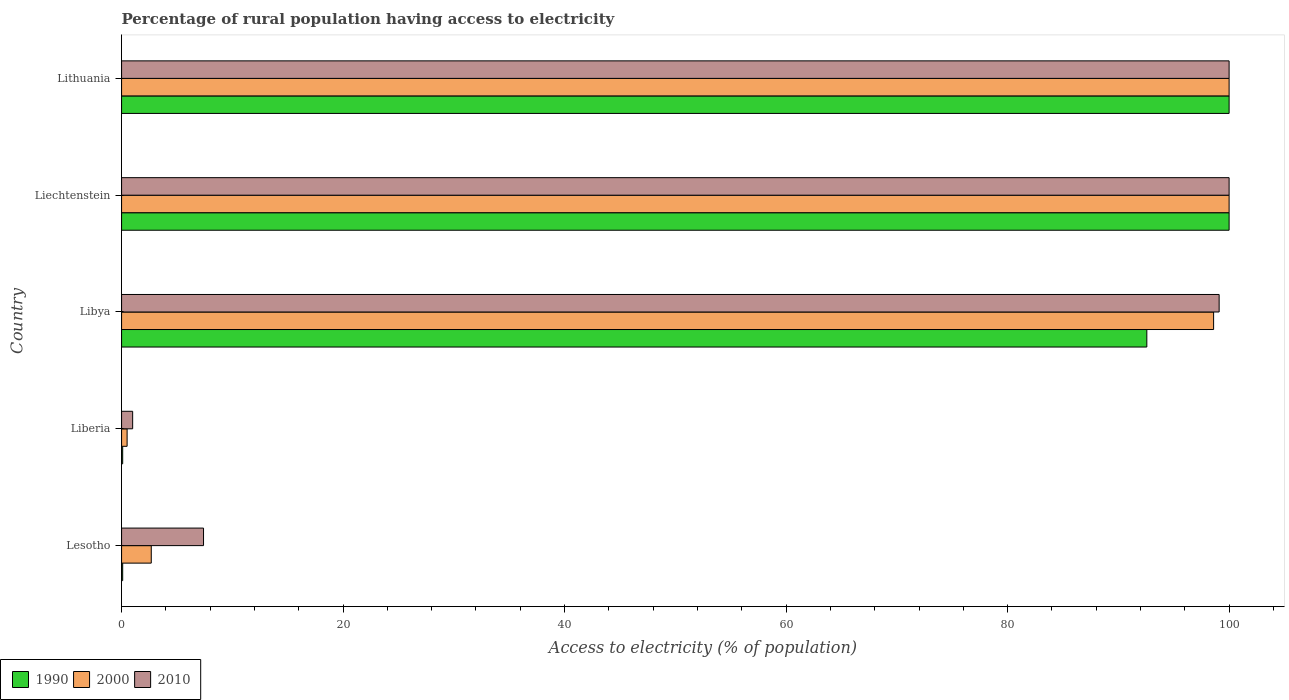How many different coloured bars are there?
Give a very brief answer. 3. How many groups of bars are there?
Offer a very short reply. 5. Are the number of bars per tick equal to the number of legend labels?
Make the answer very short. Yes. Are the number of bars on each tick of the Y-axis equal?
Offer a very short reply. Yes. What is the label of the 1st group of bars from the top?
Provide a short and direct response. Lithuania. In how many cases, is the number of bars for a given country not equal to the number of legend labels?
Provide a succinct answer. 0. What is the percentage of rural population having access to electricity in 1990 in Libya?
Provide a succinct answer. 92.57. Across all countries, what is the minimum percentage of rural population having access to electricity in 2000?
Your answer should be compact. 0.5. In which country was the percentage of rural population having access to electricity in 2000 maximum?
Ensure brevity in your answer.  Liechtenstein. In which country was the percentage of rural population having access to electricity in 2010 minimum?
Offer a very short reply. Liberia. What is the total percentage of rural population having access to electricity in 2010 in the graph?
Ensure brevity in your answer.  307.5. What is the difference between the percentage of rural population having access to electricity in 2000 in Lesotho and that in Libya?
Keep it short and to the point. -95.92. What is the difference between the percentage of rural population having access to electricity in 2010 in Lesotho and the percentage of rural population having access to electricity in 2000 in Libya?
Keep it short and to the point. -91.2. What is the average percentage of rural population having access to electricity in 2010 per country?
Ensure brevity in your answer.  61.5. What is the difference between the percentage of rural population having access to electricity in 1990 and percentage of rural population having access to electricity in 2010 in Liberia?
Your response must be concise. -0.9. In how many countries, is the percentage of rural population having access to electricity in 2000 greater than 92 %?
Keep it short and to the point. 3. What is the ratio of the percentage of rural population having access to electricity in 1990 in Libya to that in Lithuania?
Keep it short and to the point. 0.93. Is the percentage of rural population having access to electricity in 2000 in Liechtenstein less than that in Lithuania?
Your answer should be very brief. No. Is the sum of the percentage of rural population having access to electricity in 1990 in Lesotho and Liechtenstein greater than the maximum percentage of rural population having access to electricity in 2000 across all countries?
Offer a terse response. Yes. What does the 3rd bar from the top in Liechtenstein represents?
Offer a very short reply. 1990. What does the 2nd bar from the bottom in Libya represents?
Your answer should be very brief. 2000. Is it the case that in every country, the sum of the percentage of rural population having access to electricity in 2000 and percentage of rural population having access to electricity in 2010 is greater than the percentage of rural population having access to electricity in 1990?
Provide a succinct answer. Yes. How many bars are there?
Your answer should be compact. 15. How many countries are there in the graph?
Offer a terse response. 5. What is the difference between two consecutive major ticks on the X-axis?
Offer a very short reply. 20. Does the graph contain any zero values?
Ensure brevity in your answer.  No. Where does the legend appear in the graph?
Offer a very short reply. Bottom left. What is the title of the graph?
Offer a very short reply. Percentage of rural population having access to electricity. Does "1978" appear as one of the legend labels in the graph?
Give a very brief answer. No. What is the label or title of the X-axis?
Provide a succinct answer. Access to electricity (% of population). What is the Access to electricity (% of population) of 1990 in Lesotho?
Make the answer very short. 0.1. What is the Access to electricity (% of population) in 2000 in Lesotho?
Offer a terse response. 2.68. What is the Access to electricity (% of population) in 2010 in Lesotho?
Offer a terse response. 7.4. What is the Access to electricity (% of population) of 1990 in Liberia?
Give a very brief answer. 0.1. What is the Access to electricity (% of population) in 2000 in Liberia?
Your answer should be compact. 0.5. What is the Access to electricity (% of population) of 2010 in Liberia?
Offer a very short reply. 1. What is the Access to electricity (% of population) of 1990 in Libya?
Provide a short and direct response. 92.57. What is the Access to electricity (% of population) of 2000 in Libya?
Your response must be concise. 98.6. What is the Access to electricity (% of population) in 2010 in Libya?
Your answer should be compact. 99.1. What is the Access to electricity (% of population) in 1990 in Liechtenstein?
Your answer should be compact. 100. What is the Access to electricity (% of population) of 2010 in Liechtenstein?
Keep it short and to the point. 100. Across all countries, what is the maximum Access to electricity (% of population) in 1990?
Give a very brief answer. 100. What is the total Access to electricity (% of population) in 1990 in the graph?
Provide a short and direct response. 292.77. What is the total Access to electricity (% of population) in 2000 in the graph?
Offer a very short reply. 301.78. What is the total Access to electricity (% of population) in 2010 in the graph?
Give a very brief answer. 307.5. What is the difference between the Access to electricity (% of population) in 1990 in Lesotho and that in Liberia?
Your response must be concise. 0. What is the difference between the Access to electricity (% of population) of 2000 in Lesotho and that in Liberia?
Keep it short and to the point. 2.18. What is the difference between the Access to electricity (% of population) in 1990 in Lesotho and that in Libya?
Keep it short and to the point. -92.47. What is the difference between the Access to electricity (% of population) in 2000 in Lesotho and that in Libya?
Keep it short and to the point. -95.92. What is the difference between the Access to electricity (% of population) in 2010 in Lesotho and that in Libya?
Offer a very short reply. -91.7. What is the difference between the Access to electricity (% of population) in 1990 in Lesotho and that in Liechtenstein?
Provide a succinct answer. -99.9. What is the difference between the Access to electricity (% of population) in 2000 in Lesotho and that in Liechtenstein?
Keep it short and to the point. -97.32. What is the difference between the Access to electricity (% of population) of 2010 in Lesotho and that in Liechtenstein?
Offer a very short reply. -92.6. What is the difference between the Access to electricity (% of population) of 1990 in Lesotho and that in Lithuania?
Make the answer very short. -99.9. What is the difference between the Access to electricity (% of population) in 2000 in Lesotho and that in Lithuania?
Your answer should be compact. -97.32. What is the difference between the Access to electricity (% of population) of 2010 in Lesotho and that in Lithuania?
Your answer should be compact. -92.6. What is the difference between the Access to electricity (% of population) in 1990 in Liberia and that in Libya?
Offer a terse response. -92.47. What is the difference between the Access to electricity (% of population) in 2000 in Liberia and that in Libya?
Your answer should be compact. -98.1. What is the difference between the Access to electricity (% of population) of 2010 in Liberia and that in Libya?
Your answer should be compact. -98.1. What is the difference between the Access to electricity (% of population) in 1990 in Liberia and that in Liechtenstein?
Provide a succinct answer. -99.9. What is the difference between the Access to electricity (% of population) in 2000 in Liberia and that in Liechtenstein?
Offer a very short reply. -99.5. What is the difference between the Access to electricity (% of population) in 2010 in Liberia and that in Liechtenstein?
Ensure brevity in your answer.  -99. What is the difference between the Access to electricity (% of population) of 1990 in Liberia and that in Lithuania?
Provide a succinct answer. -99.9. What is the difference between the Access to electricity (% of population) in 2000 in Liberia and that in Lithuania?
Offer a terse response. -99.5. What is the difference between the Access to electricity (% of population) in 2010 in Liberia and that in Lithuania?
Your answer should be compact. -99. What is the difference between the Access to electricity (% of population) in 1990 in Libya and that in Liechtenstein?
Make the answer very short. -7.43. What is the difference between the Access to electricity (% of population) of 2000 in Libya and that in Liechtenstein?
Your response must be concise. -1.4. What is the difference between the Access to electricity (% of population) in 2010 in Libya and that in Liechtenstein?
Give a very brief answer. -0.9. What is the difference between the Access to electricity (% of population) of 1990 in Libya and that in Lithuania?
Your answer should be very brief. -7.43. What is the difference between the Access to electricity (% of population) of 2010 in Libya and that in Lithuania?
Offer a very short reply. -0.9. What is the difference between the Access to electricity (% of population) in 2000 in Liechtenstein and that in Lithuania?
Provide a short and direct response. 0. What is the difference between the Access to electricity (% of population) of 1990 in Lesotho and the Access to electricity (% of population) of 2000 in Liberia?
Offer a terse response. -0.4. What is the difference between the Access to electricity (% of population) in 1990 in Lesotho and the Access to electricity (% of population) in 2010 in Liberia?
Offer a very short reply. -0.9. What is the difference between the Access to electricity (% of population) in 2000 in Lesotho and the Access to electricity (% of population) in 2010 in Liberia?
Provide a succinct answer. 1.68. What is the difference between the Access to electricity (% of population) of 1990 in Lesotho and the Access to electricity (% of population) of 2000 in Libya?
Your answer should be very brief. -98.5. What is the difference between the Access to electricity (% of population) of 1990 in Lesotho and the Access to electricity (% of population) of 2010 in Libya?
Your answer should be very brief. -99. What is the difference between the Access to electricity (% of population) in 2000 in Lesotho and the Access to electricity (% of population) in 2010 in Libya?
Keep it short and to the point. -96.42. What is the difference between the Access to electricity (% of population) in 1990 in Lesotho and the Access to electricity (% of population) in 2000 in Liechtenstein?
Offer a very short reply. -99.9. What is the difference between the Access to electricity (% of population) of 1990 in Lesotho and the Access to electricity (% of population) of 2010 in Liechtenstein?
Provide a short and direct response. -99.9. What is the difference between the Access to electricity (% of population) of 2000 in Lesotho and the Access to electricity (% of population) of 2010 in Liechtenstein?
Your answer should be compact. -97.32. What is the difference between the Access to electricity (% of population) of 1990 in Lesotho and the Access to electricity (% of population) of 2000 in Lithuania?
Keep it short and to the point. -99.9. What is the difference between the Access to electricity (% of population) in 1990 in Lesotho and the Access to electricity (% of population) in 2010 in Lithuania?
Your answer should be very brief. -99.9. What is the difference between the Access to electricity (% of population) in 2000 in Lesotho and the Access to electricity (% of population) in 2010 in Lithuania?
Your response must be concise. -97.32. What is the difference between the Access to electricity (% of population) of 1990 in Liberia and the Access to electricity (% of population) of 2000 in Libya?
Offer a very short reply. -98.5. What is the difference between the Access to electricity (% of population) in 1990 in Liberia and the Access to electricity (% of population) in 2010 in Libya?
Provide a short and direct response. -99. What is the difference between the Access to electricity (% of population) of 2000 in Liberia and the Access to electricity (% of population) of 2010 in Libya?
Offer a very short reply. -98.6. What is the difference between the Access to electricity (% of population) in 1990 in Liberia and the Access to electricity (% of population) in 2000 in Liechtenstein?
Ensure brevity in your answer.  -99.9. What is the difference between the Access to electricity (% of population) of 1990 in Liberia and the Access to electricity (% of population) of 2010 in Liechtenstein?
Your response must be concise. -99.9. What is the difference between the Access to electricity (% of population) of 2000 in Liberia and the Access to electricity (% of population) of 2010 in Liechtenstein?
Your answer should be compact. -99.5. What is the difference between the Access to electricity (% of population) of 1990 in Liberia and the Access to electricity (% of population) of 2000 in Lithuania?
Make the answer very short. -99.9. What is the difference between the Access to electricity (% of population) of 1990 in Liberia and the Access to electricity (% of population) of 2010 in Lithuania?
Provide a short and direct response. -99.9. What is the difference between the Access to electricity (% of population) in 2000 in Liberia and the Access to electricity (% of population) in 2010 in Lithuania?
Provide a short and direct response. -99.5. What is the difference between the Access to electricity (% of population) in 1990 in Libya and the Access to electricity (% of population) in 2000 in Liechtenstein?
Keep it short and to the point. -7.43. What is the difference between the Access to electricity (% of population) of 1990 in Libya and the Access to electricity (% of population) of 2010 in Liechtenstein?
Your response must be concise. -7.43. What is the difference between the Access to electricity (% of population) of 1990 in Libya and the Access to electricity (% of population) of 2000 in Lithuania?
Keep it short and to the point. -7.43. What is the difference between the Access to electricity (% of population) of 1990 in Libya and the Access to electricity (% of population) of 2010 in Lithuania?
Your answer should be very brief. -7.43. What is the difference between the Access to electricity (% of population) in 1990 in Liechtenstein and the Access to electricity (% of population) in 2010 in Lithuania?
Your answer should be very brief. 0. What is the difference between the Access to electricity (% of population) in 2000 in Liechtenstein and the Access to electricity (% of population) in 2010 in Lithuania?
Provide a short and direct response. 0. What is the average Access to electricity (% of population) of 1990 per country?
Provide a short and direct response. 58.55. What is the average Access to electricity (% of population) in 2000 per country?
Give a very brief answer. 60.36. What is the average Access to electricity (% of population) in 2010 per country?
Provide a short and direct response. 61.5. What is the difference between the Access to electricity (% of population) of 1990 and Access to electricity (% of population) of 2000 in Lesotho?
Provide a short and direct response. -2.58. What is the difference between the Access to electricity (% of population) in 2000 and Access to electricity (% of population) in 2010 in Lesotho?
Make the answer very short. -4.72. What is the difference between the Access to electricity (% of population) of 1990 and Access to electricity (% of population) of 2000 in Libya?
Provide a short and direct response. -6.03. What is the difference between the Access to electricity (% of population) in 1990 and Access to electricity (% of population) in 2010 in Libya?
Make the answer very short. -6.53. What is the difference between the Access to electricity (% of population) of 2000 and Access to electricity (% of population) of 2010 in Libya?
Keep it short and to the point. -0.5. What is the difference between the Access to electricity (% of population) in 1990 and Access to electricity (% of population) in 2000 in Liechtenstein?
Ensure brevity in your answer.  0. What is the ratio of the Access to electricity (% of population) of 1990 in Lesotho to that in Liberia?
Provide a succinct answer. 1. What is the ratio of the Access to electricity (% of population) in 2000 in Lesotho to that in Liberia?
Provide a short and direct response. 5.36. What is the ratio of the Access to electricity (% of population) in 2010 in Lesotho to that in Liberia?
Offer a very short reply. 7.4. What is the ratio of the Access to electricity (% of population) of 1990 in Lesotho to that in Libya?
Keep it short and to the point. 0. What is the ratio of the Access to electricity (% of population) of 2000 in Lesotho to that in Libya?
Provide a succinct answer. 0.03. What is the ratio of the Access to electricity (% of population) of 2010 in Lesotho to that in Libya?
Offer a very short reply. 0.07. What is the ratio of the Access to electricity (% of population) in 1990 in Lesotho to that in Liechtenstein?
Give a very brief answer. 0. What is the ratio of the Access to electricity (% of population) of 2000 in Lesotho to that in Liechtenstein?
Provide a succinct answer. 0.03. What is the ratio of the Access to electricity (% of population) of 2010 in Lesotho to that in Liechtenstein?
Offer a terse response. 0.07. What is the ratio of the Access to electricity (% of population) of 1990 in Lesotho to that in Lithuania?
Make the answer very short. 0. What is the ratio of the Access to electricity (% of population) in 2000 in Lesotho to that in Lithuania?
Provide a short and direct response. 0.03. What is the ratio of the Access to electricity (% of population) in 2010 in Lesotho to that in Lithuania?
Your response must be concise. 0.07. What is the ratio of the Access to electricity (% of population) in 1990 in Liberia to that in Libya?
Offer a very short reply. 0. What is the ratio of the Access to electricity (% of population) of 2000 in Liberia to that in Libya?
Keep it short and to the point. 0.01. What is the ratio of the Access to electricity (% of population) of 2010 in Liberia to that in Libya?
Keep it short and to the point. 0.01. What is the ratio of the Access to electricity (% of population) in 1990 in Liberia to that in Liechtenstein?
Offer a very short reply. 0. What is the ratio of the Access to electricity (% of population) in 2000 in Liberia to that in Liechtenstein?
Your answer should be very brief. 0.01. What is the ratio of the Access to electricity (% of population) of 2010 in Liberia to that in Liechtenstein?
Offer a very short reply. 0.01. What is the ratio of the Access to electricity (% of population) of 1990 in Liberia to that in Lithuania?
Your response must be concise. 0. What is the ratio of the Access to electricity (% of population) of 2000 in Liberia to that in Lithuania?
Provide a short and direct response. 0.01. What is the ratio of the Access to electricity (% of population) of 2010 in Liberia to that in Lithuania?
Offer a terse response. 0.01. What is the ratio of the Access to electricity (% of population) in 1990 in Libya to that in Liechtenstein?
Provide a succinct answer. 0.93. What is the ratio of the Access to electricity (% of population) in 2000 in Libya to that in Liechtenstein?
Keep it short and to the point. 0.99. What is the ratio of the Access to electricity (% of population) of 2010 in Libya to that in Liechtenstein?
Give a very brief answer. 0.99. What is the ratio of the Access to electricity (% of population) in 1990 in Libya to that in Lithuania?
Give a very brief answer. 0.93. What is the ratio of the Access to electricity (% of population) in 2010 in Libya to that in Lithuania?
Your response must be concise. 0.99. What is the ratio of the Access to electricity (% of population) of 1990 in Liechtenstein to that in Lithuania?
Provide a succinct answer. 1. What is the ratio of the Access to electricity (% of population) in 2000 in Liechtenstein to that in Lithuania?
Make the answer very short. 1. What is the ratio of the Access to electricity (% of population) of 2010 in Liechtenstein to that in Lithuania?
Offer a very short reply. 1. What is the difference between the highest and the second highest Access to electricity (% of population) of 1990?
Give a very brief answer. 0. What is the difference between the highest and the lowest Access to electricity (% of population) in 1990?
Your response must be concise. 99.9. What is the difference between the highest and the lowest Access to electricity (% of population) of 2000?
Offer a terse response. 99.5. What is the difference between the highest and the lowest Access to electricity (% of population) of 2010?
Keep it short and to the point. 99. 